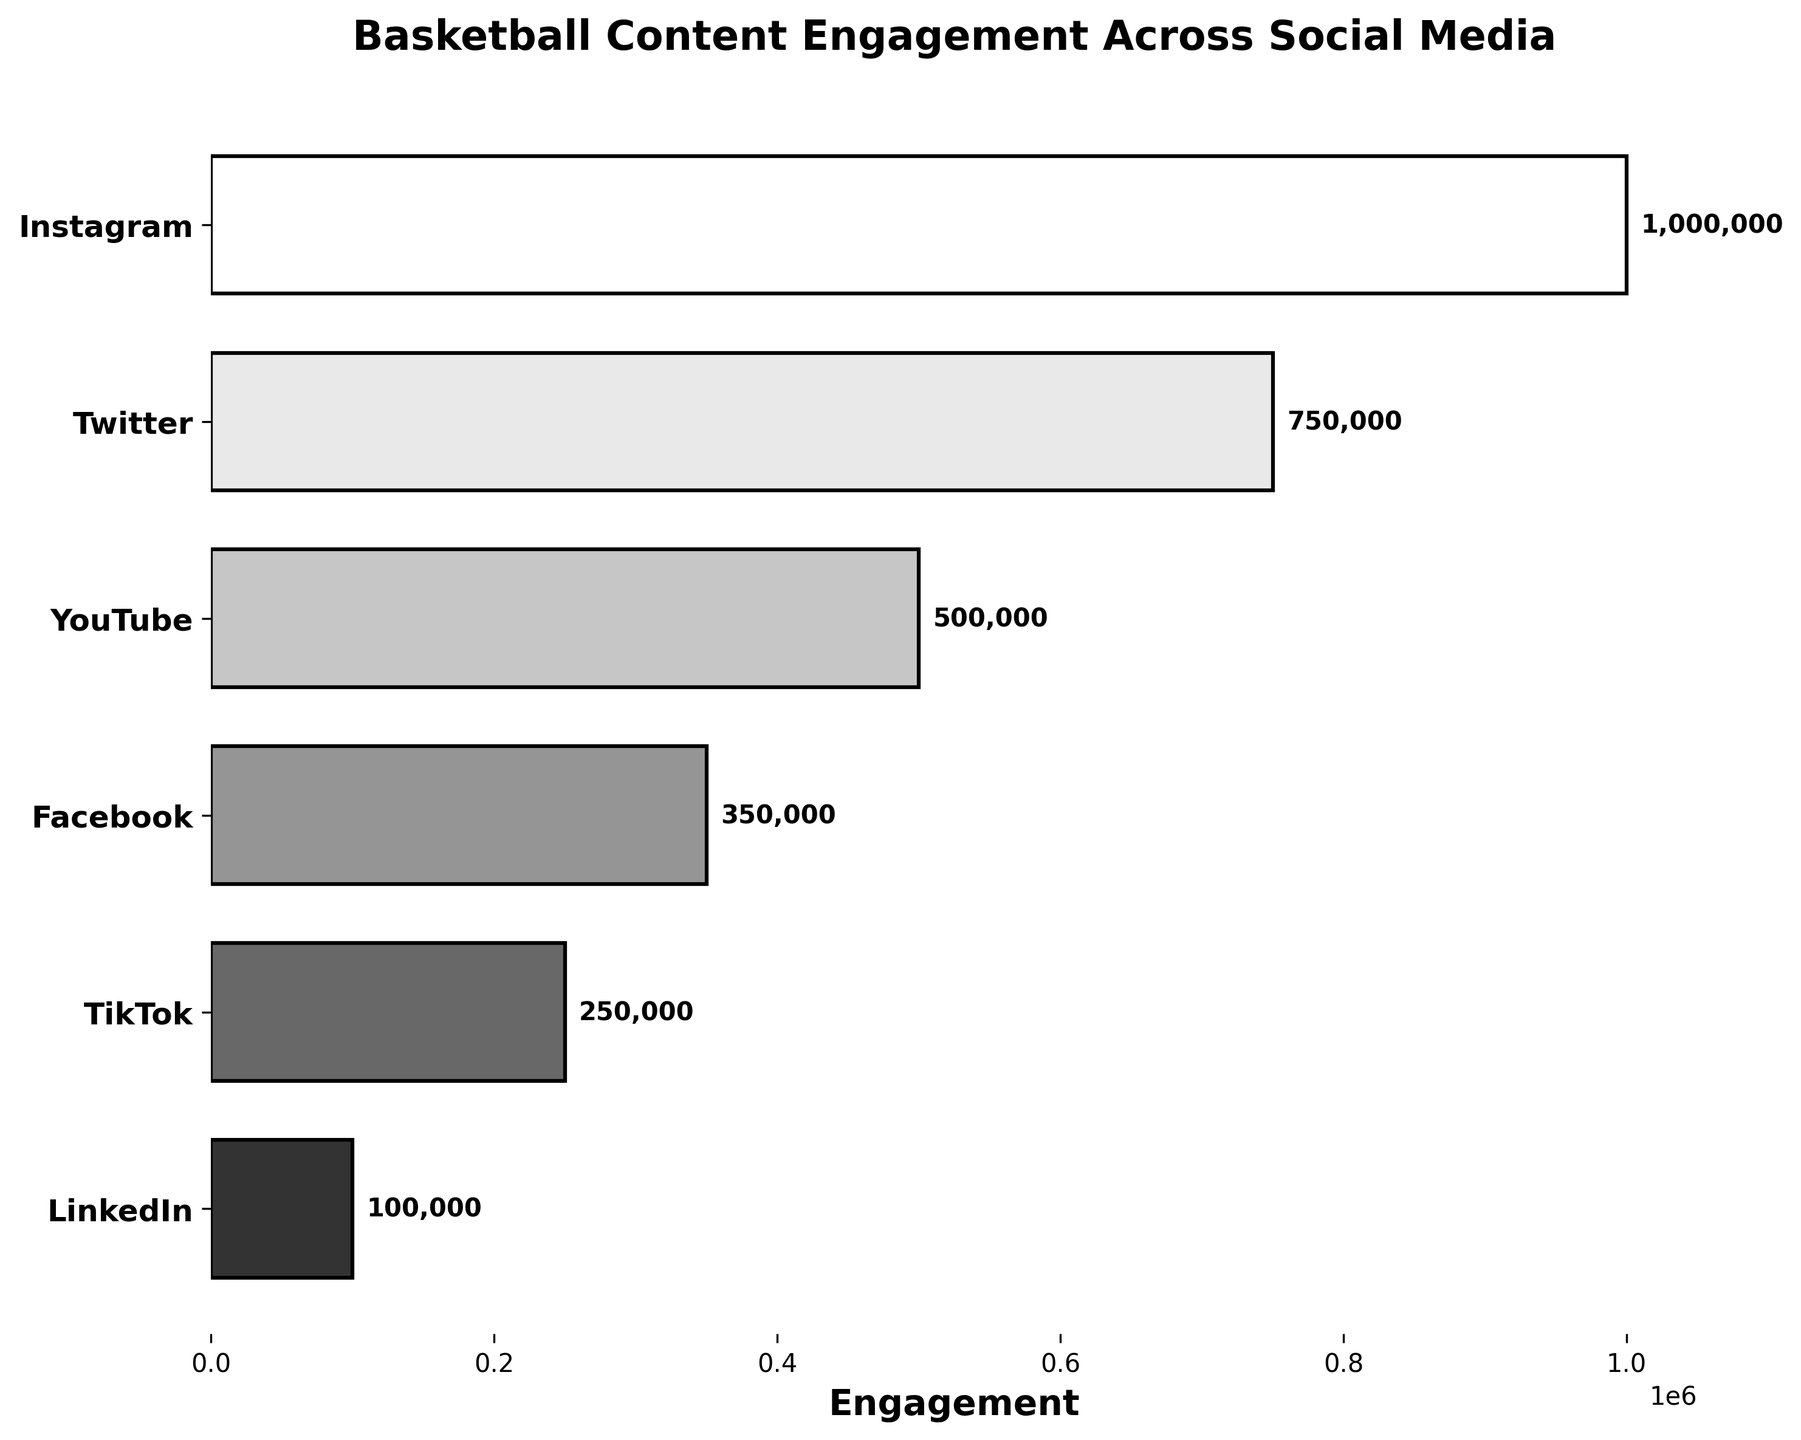How many social media platforms are shown in the figure? There are six different social media platforms listed along the y-axis.
Answer: 6 Which social media platform has the highest engagement? The topmost bar, representing "Instagram", has the highest engagement according to the figure.
Answer: Instagram Which platform has the least engagement and what is its value? The bottommost bar, representing "LinkedIn", has the least engagement with a value of 100,000.
Answer: LinkedIn, 100,000 What is the total engagement across all platforms? Summing values: 1,000,000 (Instagram) + 750,000 (Twitter) + 500,000 (YouTube) + 350,000 (Facebook) + 250,000 (TikTok) + 100,000 (LinkedIn) = 2,950,000.
Answer: 2,950,000 What's the average engagement per platform? Total engagement is 2,950,000; divide by 6 platforms. Average = 2,950,000 / 6 = ~491,667.
Answer: 491,667 Which platform has exactly 500,000 engagements? The third bar from the top, representing "YouTube", has an engagement value of 500,000.
Answer: YouTube How much more engagement does Instagram have compared to TikTok? Instagram has 1,000,000; TikTok has 250,000. Difference = 1,000,000 - 250,000 = 750,000.
Answer: 750,000 Among the platforms listed, which types of content have the highest engagement? The platform with the highest engagement, Instagram, features "Game Highlights".
Answer: Game Highlights What percentage of the total engagement does Facebook account for? Facebook engagement is 350,000. Total is 2,950,000. Percentage = (350,000 / 2,950,000) * 100 ≈ 11.86%.
Answer: 11.86% Rank the platforms according to their engagement from highest to lowest. The platforms are ranked as follows: Instagram (1,000,000), Twitter (750,000), YouTube (500,000), Facebook (350,000), TikTok (250,000), LinkedIn (100,000).
Answer: Instagram, Twitter, YouTube, Facebook, TikTok, LinkedIn 